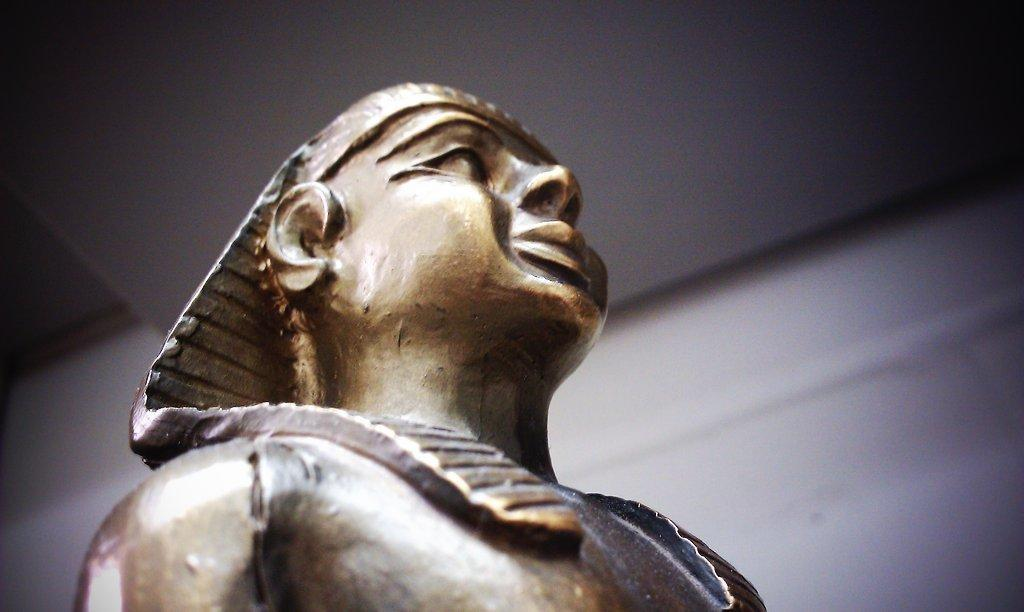What is the main subject of the picture? There is a statue of a man in the picture. Can you describe the background of the image? The background of the image is blurred. What type of toothpaste is the man using in the image? There is no toothpaste present in the image, as it features a statue of a man. How does the man's hair look in the image? The image features a statue, which does not have hair, so it cannot be described. 